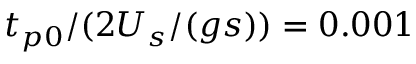<formula> <loc_0><loc_0><loc_500><loc_500>t _ { p 0 } / ( 2 U _ { s } / ( g s ) ) = 0 . 0 0 1</formula> 